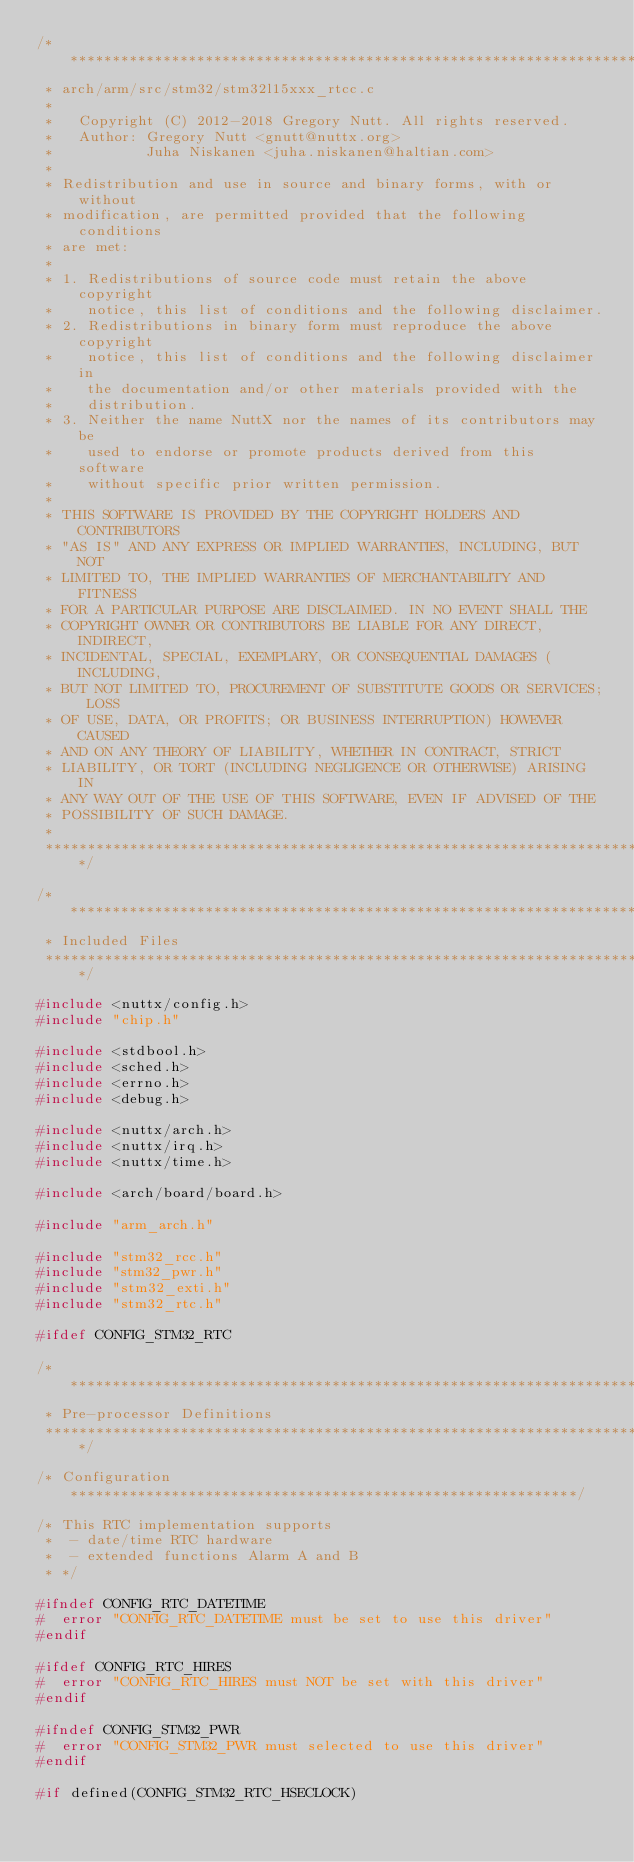<code> <loc_0><loc_0><loc_500><loc_500><_C_>/****************************************************************************
 * arch/arm/src/stm32/stm32l15xxx_rtcc.c
 *
 *   Copyright (C) 2012-2018 Gregory Nutt. All rights reserved.
 *   Author: Gregory Nutt <gnutt@nuttx.org>
 *           Juha Niskanen <juha.niskanen@haltian.com>
 *
 * Redistribution and use in source and binary forms, with or without
 * modification, are permitted provided that the following conditions
 * are met:
 *
 * 1. Redistributions of source code must retain the above copyright
 *    notice, this list of conditions and the following disclaimer.
 * 2. Redistributions in binary form must reproduce the above copyright
 *    notice, this list of conditions and the following disclaimer in
 *    the documentation and/or other materials provided with the
 *    distribution.
 * 3. Neither the name NuttX nor the names of its contributors may be
 *    used to endorse or promote products derived from this software
 *    without specific prior written permission.
 *
 * THIS SOFTWARE IS PROVIDED BY THE COPYRIGHT HOLDERS AND CONTRIBUTORS
 * "AS IS" AND ANY EXPRESS OR IMPLIED WARRANTIES, INCLUDING, BUT NOT
 * LIMITED TO, THE IMPLIED WARRANTIES OF MERCHANTABILITY AND FITNESS
 * FOR A PARTICULAR PURPOSE ARE DISCLAIMED. IN NO EVENT SHALL THE
 * COPYRIGHT OWNER OR CONTRIBUTORS BE LIABLE FOR ANY DIRECT, INDIRECT,
 * INCIDENTAL, SPECIAL, EXEMPLARY, OR CONSEQUENTIAL DAMAGES (INCLUDING,
 * BUT NOT LIMITED TO, PROCUREMENT OF SUBSTITUTE GOODS OR SERVICES; LOSS
 * OF USE, DATA, OR PROFITS; OR BUSINESS INTERRUPTION) HOWEVER CAUSED
 * AND ON ANY THEORY OF LIABILITY, WHETHER IN CONTRACT, STRICT
 * LIABILITY, OR TORT (INCLUDING NEGLIGENCE OR OTHERWISE) ARISING IN
 * ANY WAY OUT OF THE USE OF THIS SOFTWARE, EVEN IF ADVISED OF THE
 * POSSIBILITY OF SUCH DAMAGE.
 *
 ****************************************************************************/

/****************************************************************************
 * Included Files
 ****************************************************************************/

#include <nuttx/config.h>
#include "chip.h"

#include <stdbool.h>
#include <sched.h>
#include <errno.h>
#include <debug.h>

#include <nuttx/arch.h>
#include <nuttx/irq.h>
#include <nuttx/time.h>

#include <arch/board/board.h>

#include "arm_arch.h"

#include "stm32_rcc.h"
#include "stm32_pwr.h"
#include "stm32_exti.h"
#include "stm32_rtc.h"

#ifdef CONFIG_STM32_RTC

/****************************************************************************
 * Pre-processor Definitions
 ****************************************************************************/

/* Configuration ************************************************************/

/* This RTC implementation supports
 *  - date/time RTC hardware
 *  - extended functions Alarm A and B
 * */

#ifndef CONFIG_RTC_DATETIME
#  error "CONFIG_RTC_DATETIME must be set to use this driver"
#endif

#ifdef CONFIG_RTC_HIRES
#  error "CONFIG_RTC_HIRES must NOT be set with this driver"
#endif

#ifndef CONFIG_STM32_PWR
#  error "CONFIG_STM32_PWR must selected to use this driver"
#endif

#if defined(CONFIG_STM32_RTC_HSECLOCK)</code> 